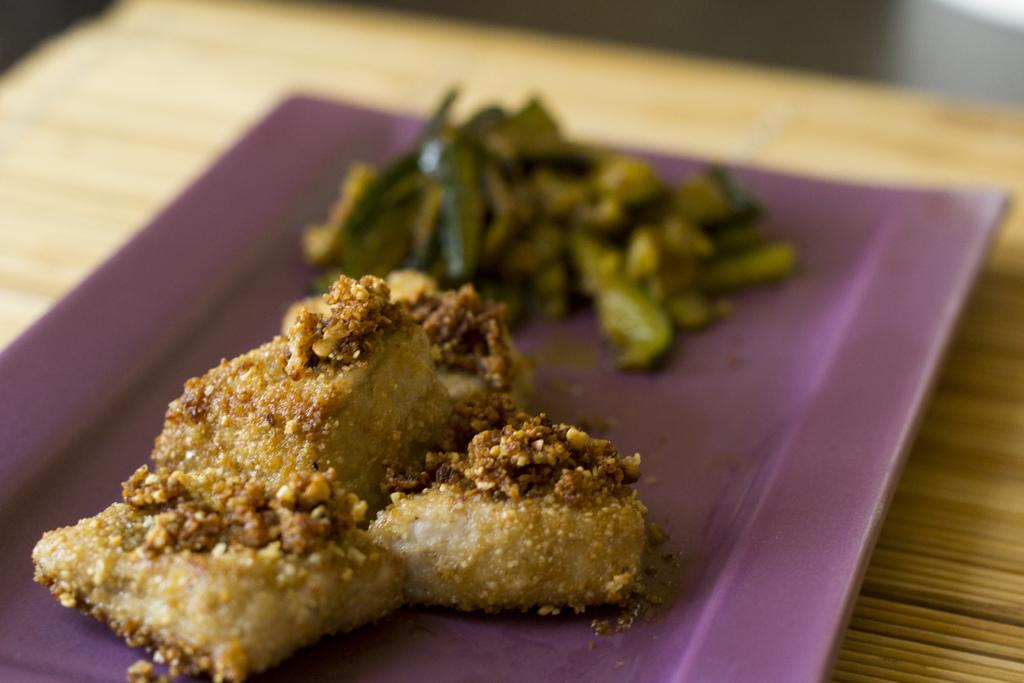What is located in the center of the image? There is a tray in the center of the image. What is on the tray in the image? The tray contains food items. How does the income of the person in the image change over time? There is no information about the person's income in the image, so it cannot be determined. 